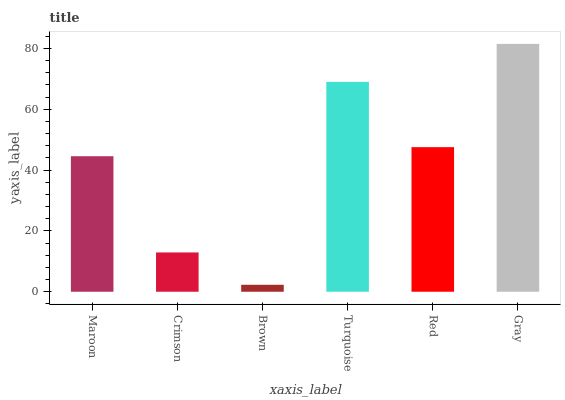Is Brown the minimum?
Answer yes or no. Yes. Is Gray the maximum?
Answer yes or no. Yes. Is Crimson the minimum?
Answer yes or no. No. Is Crimson the maximum?
Answer yes or no. No. Is Maroon greater than Crimson?
Answer yes or no. Yes. Is Crimson less than Maroon?
Answer yes or no. Yes. Is Crimson greater than Maroon?
Answer yes or no. No. Is Maroon less than Crimson?
Answer yes or no. No. Is Red the high median?
Answer yes or no. Yes. Is Maroon the low median?
Answer yes or no. Yes. Is Maroon the high median?
Answer yes or no. No. Is Crimson the low median?
Answer yes or no. No. 